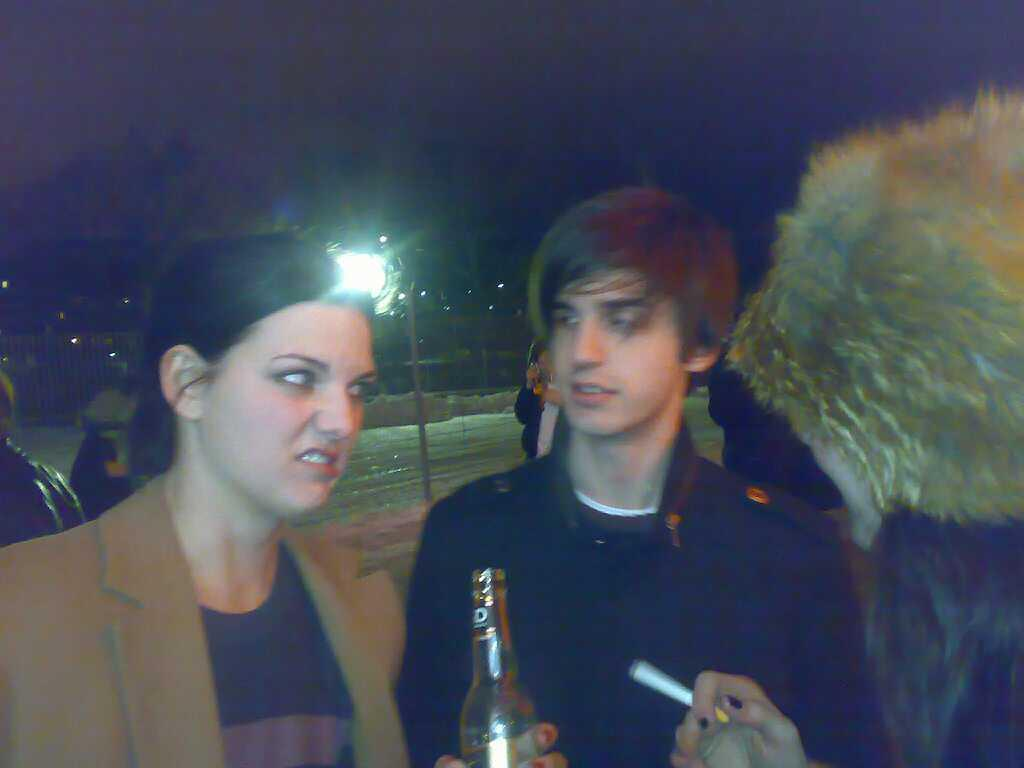How many people are in the image? There are two people in the image: a woman and a man. What is the woman holding in the image? The woman is holding a wine bottle. Can you describe the background of the image? There is a light on a street lamp in the background. What type of stamp can be seen on the pear in the image? There is no pear or stamp present in the image. Is there a plant visible in the image? The provided facts do not mention any plants in the image. 